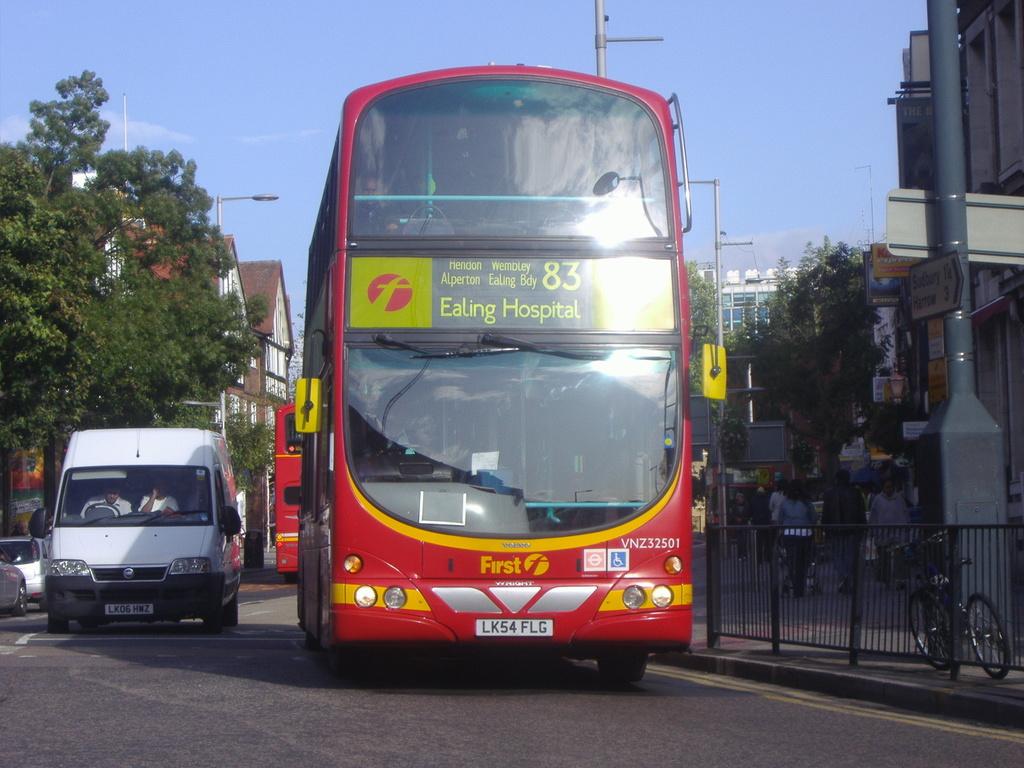What hospital is on this bus route?
Your answer should be compact. Ealing hospital. What is written on the bus in yellow?
Give a very brief answer. First. 